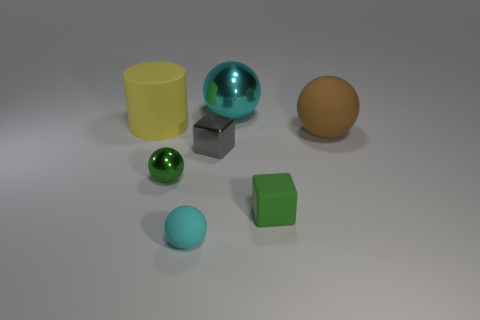Subtract all brown rubber spheres. How many spheres are left? 3 Subtract all green balls. How many balls are left? 3 Add 1 big cylinders. How many objects exist? 8 Subtract all red balls. Subtract all green blocks. How many balls are left? 4 Subtract all blocks. How many objects are left? 5 Add 7 cubes. How many cubes are left? 9 Add 7 gray shiny cubes. How many gray shiny cubes exist? 8 Subtract 0 green cylinders. How many objects are left? 7 Subtract all big blue metal cylinders. Subtract all green shiny things. How many objects are left? 6 